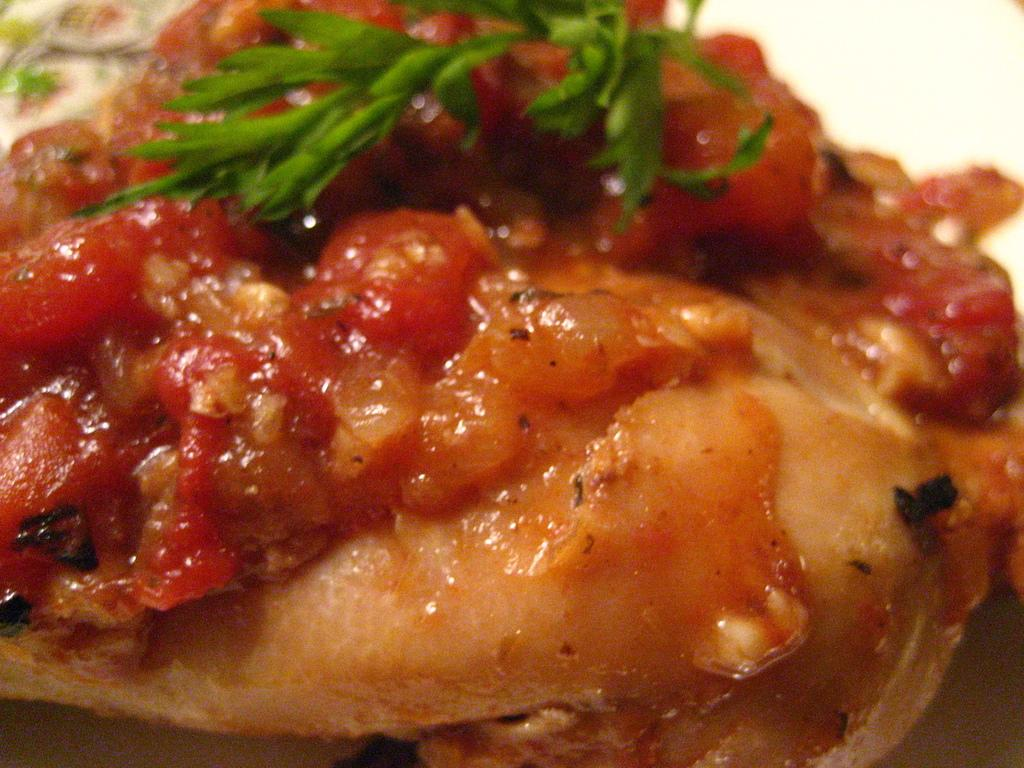What is the appearance of the food item in the image? The food item has leaves and ingredients on it. What can be observed about the background of the image? The background of the image is white in color. How many grapes are being talked about in the image? There are no grapes or any indication of a conversation in the image. What type of trousers are being worn by the person in the image? There is no person or trousers present in the image. 